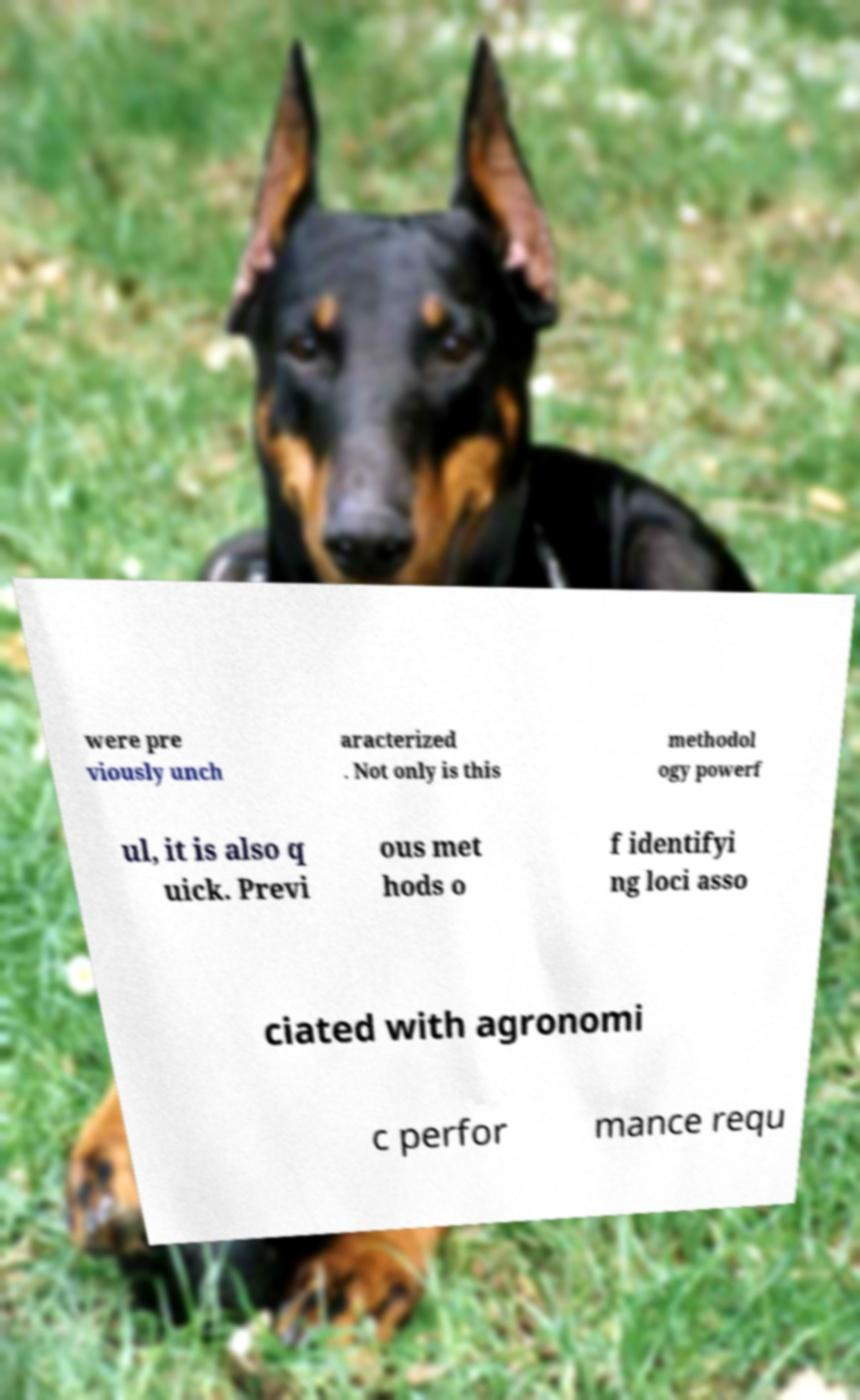I need the written content from this picture converted into text. Can you do that? were pre viously unch aracterized . Not only is this methodol ogy powerf ul, it is also q uick. Previ ous met hods o f identifyi ng loci asso ciated with agronomi c perfor mance requ 